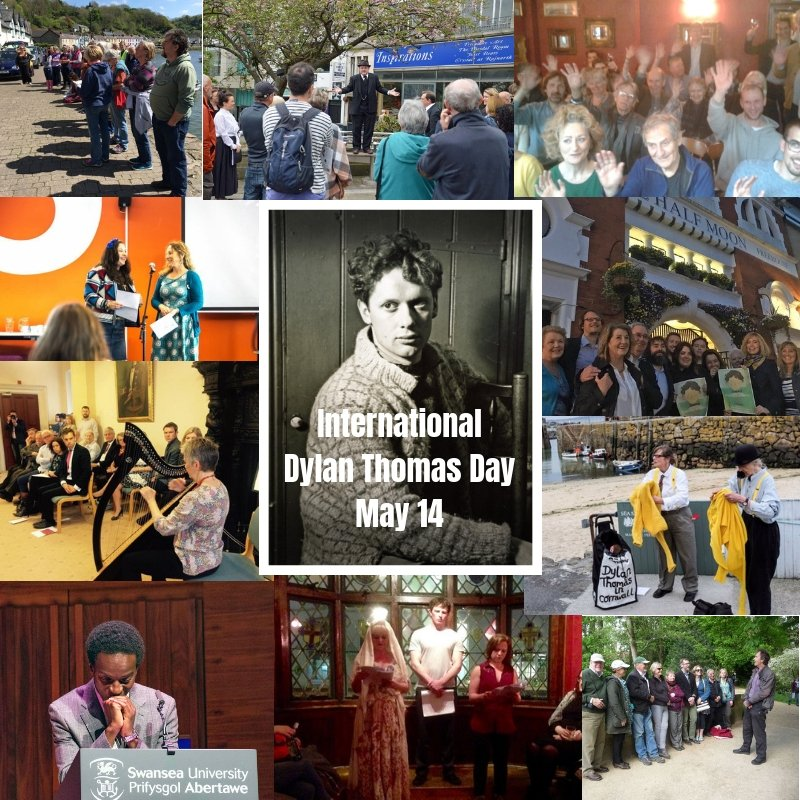What kind of discussions might be happening in the top right photo where people are raising their hands? In the top right photo, the group of people raising their hands likely indicates an interactive session, such as a Q&A or a workshop. Discussions could revolve around interpreting Dylan Thomas's works, sharing personal insights and experiences related to his poetry, or exploring the themes and stylistic elements that define his literary contributions. Attendees might be enthusiastically participating, eager to delve deeper into Thomas's influence and his unique approach to storytelling. The raised hands suggest a vibrant exchange of ideas, with participants actively engaging and contributing to the conversation. 